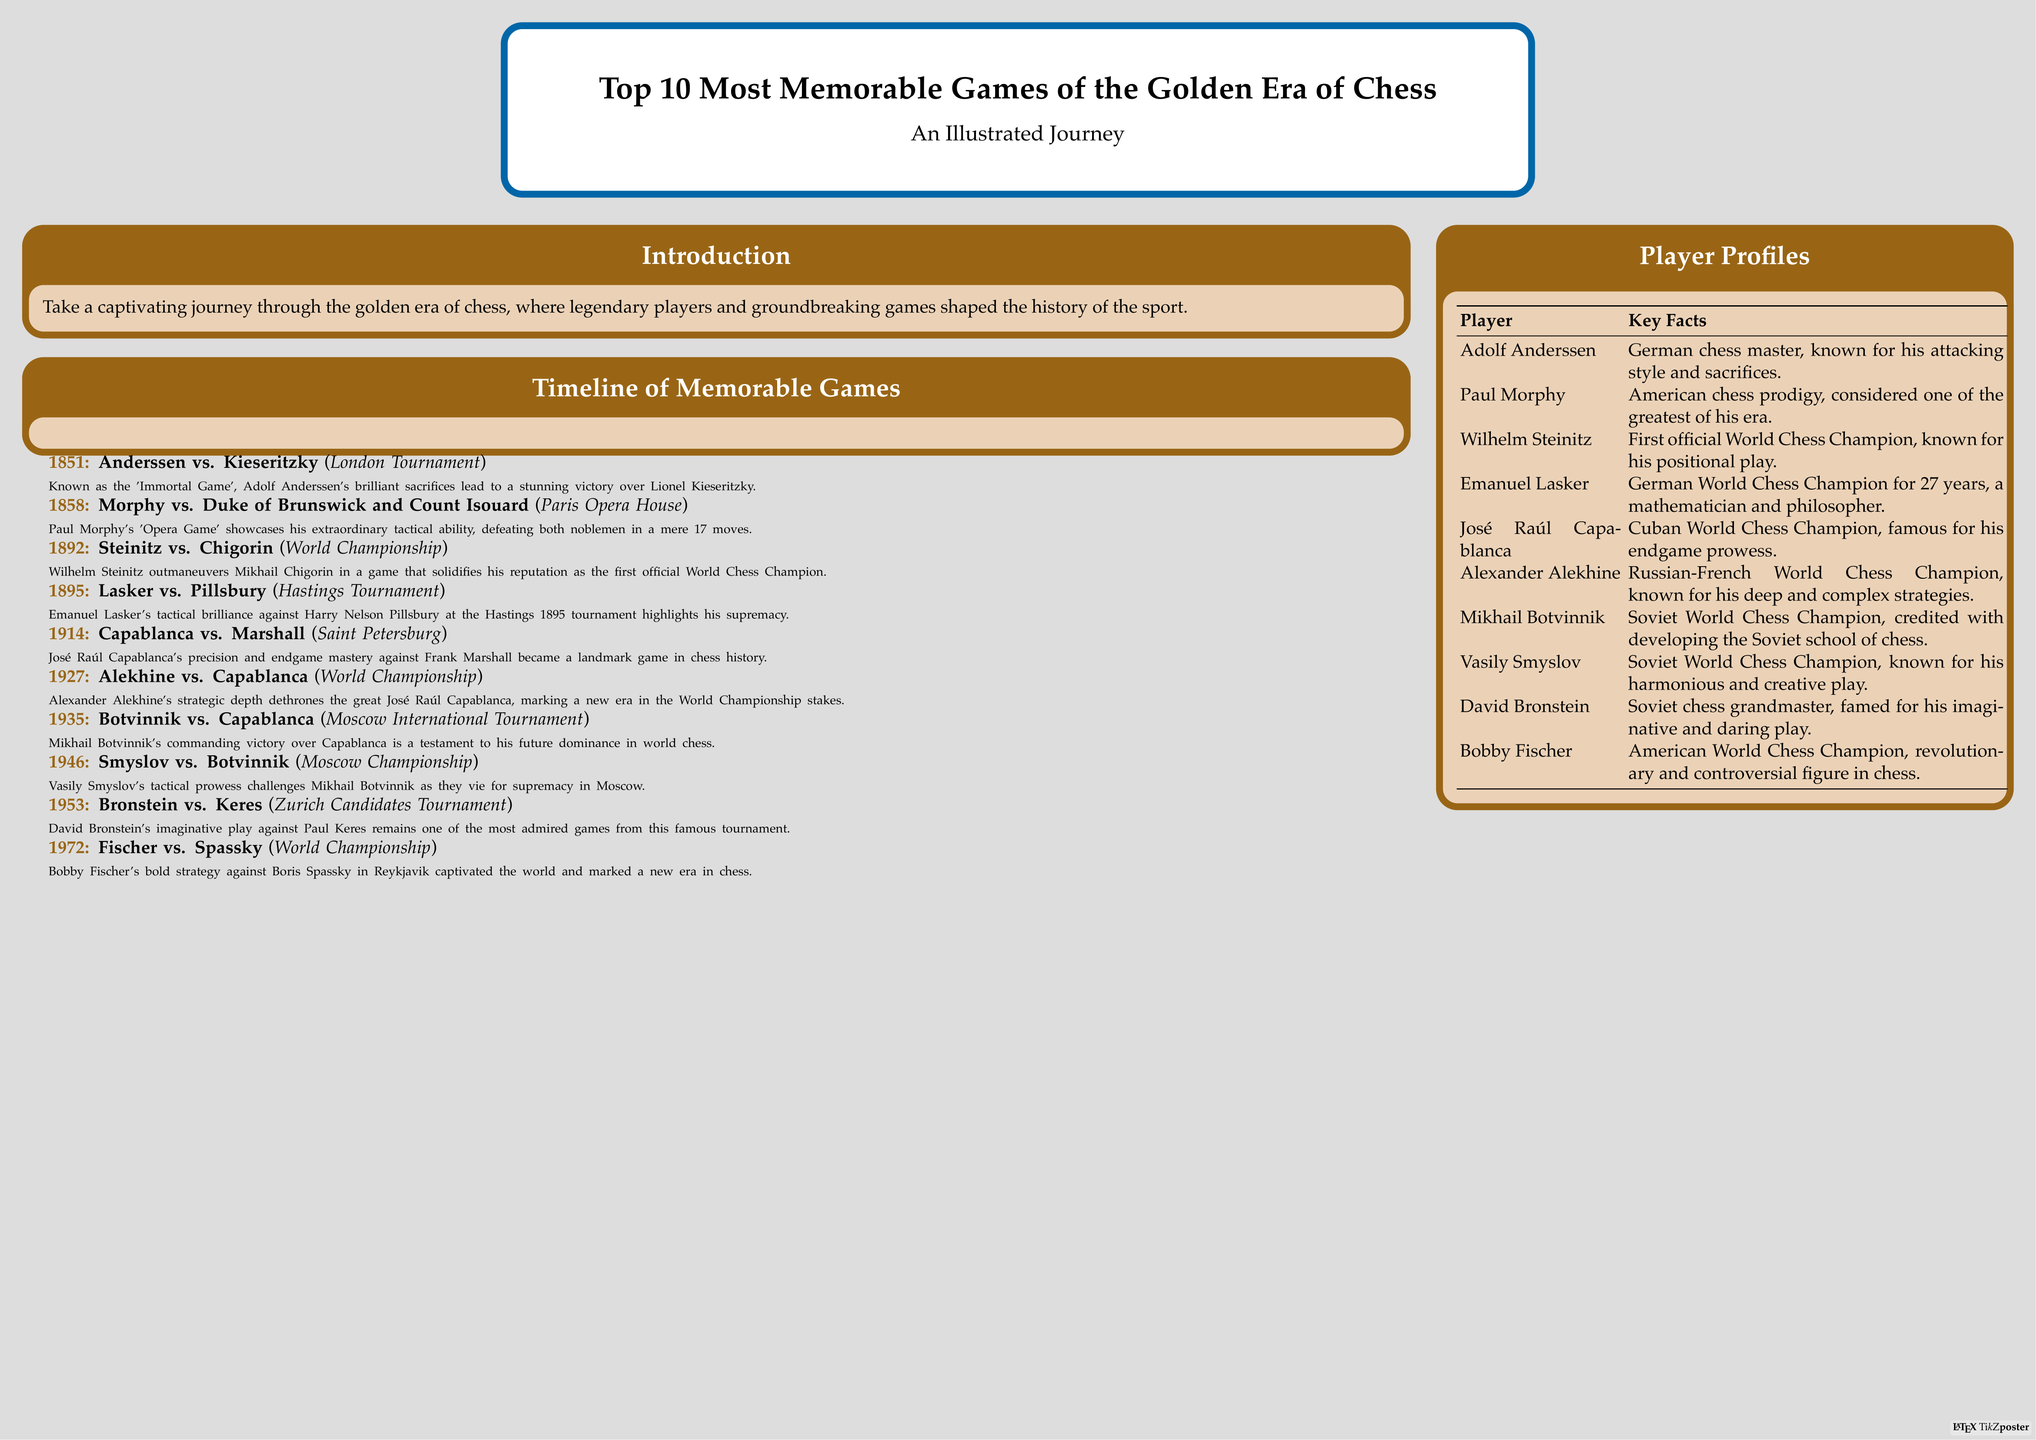What is the title of the poster? The title clearly states the subject matter of the poster, which is the focus of the illustrated journey.
Answer: Top 10 Most Memorable Games of the Golden Era of Chess Who won the 'Immortal Game'? This game is well-known in chess history for its extraordinary sacrifices made by Anderssen.
Answer: Adolf Anderssen In what year did the game between Lasker and Pillsbury take place? The year is specified in the timeline section alongside the game details, helping to anchor its historical context.
Answer: 1895 Which city hosted the World Championship match between Alekhine and Capablanca? The event's location is an essential part of understanding the game's historical backdrop.
Answer: Not specified (World Championship) Who is known for his endgame prowess? This fact highlights Capablanca's strength as a player, emphasizing his specialty in chess strategy.
Answer: José Raúl Capablanca What is the primary theme of the poster? The theme encapsulates the overall focus and intention of the illustrated journey depicted in the document.
Answer: Memorable games of the Golden Era Which player is associated with the 'Opera Game'? This name is closely associated with a famous match that demonstrates outstanding tactical ability.
Answer: Paul Morphy How many games are listed in the timeline? The number of games aids in understanding the scope and content of the poster.
Answer: 10 What significant achievement is Wilhelm Steinitz known for? This highlights his contribution to chess, specifically his role in the history of the World Chess Championship.
Answer: First official World Chess Champion 